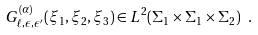<formula> <loc_0><loc_0><loc_500><loc_500>G ^ { ( \alpha ) } _ { \ell , \epsilon , \epsilon ^ { \prime } } ( \xi _ { 1 } , \xi _ { 2 } , \xi _ { 3 } ) \in L ^ { 2 } ( \Sigma _ { 1 } \times \Sigma _ { 1 } \times \Sigma _ { 2 } ) \ .</formula> 